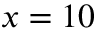Convert formula to latex. <formula><loc_0><loc_0><loc_500><loc_500>x = 1 0</formula> 